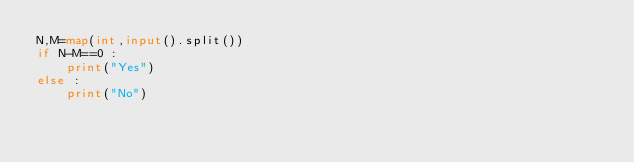Convert code to text. <code><loc_0><loc_0><loc_500><loc_500><_Python_>N,M=map(int,input().split())   
if N-M==0 :
    print("Yes")
else :
    print("No") </code> 